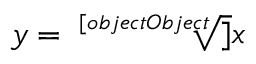<formula> <loc_0><loc_0><loc_500><loc_500>y = { \sqrt { [ } [ o b j e c t O b j e c t ] ] { x } }</formula> 